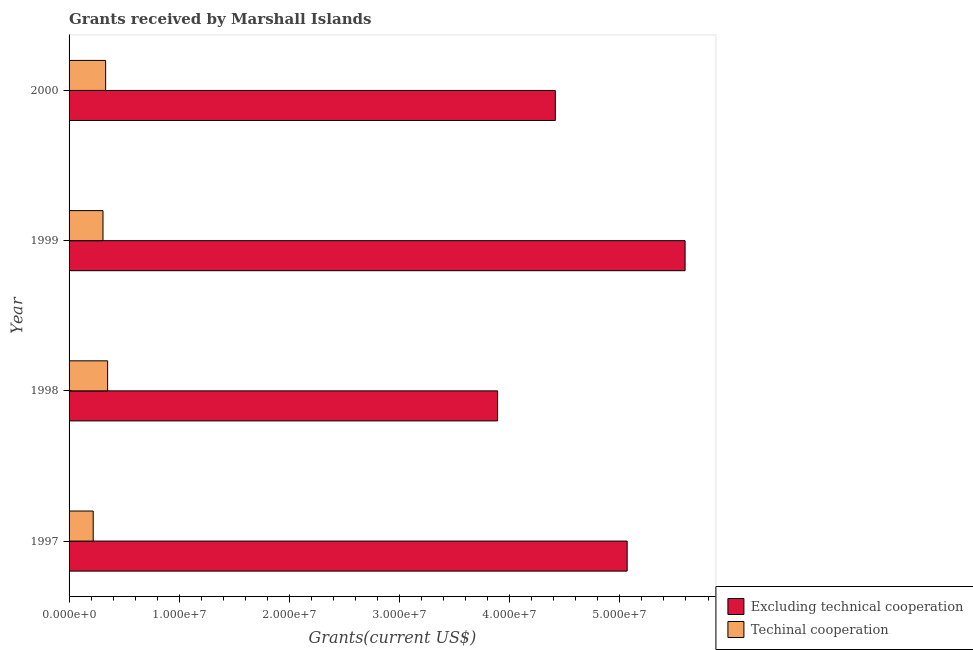How many different coloured bars are there?
Offer a very short reply. 2. How many groups of bars are there?
Ensure brevity in your answer.  4. What is the label of the 3rd group of bars from the top?
Your answer should be very brief. 1998. In how many cases, is the number of bars for a given year not equal to the number of legend labels?
Keep it short and to the point. 0. What is the amount of grants received(including technical cooperation) in 1997?
Ensure brevity in your answer.  2.19e+06. Across all years, what is the maximum amount of grants received(including technical cooperation)?
Provide a succinct answer. 3.50e+06. Across all years, what is the minimum amount of grants received(excluding technical cooperation)?
Give a very brief answer. 3.89e+07. What is the total amount of grants received(including technical cooperation) in the graph?
Keep it short and to the point. 1.21e+07. What is the difference between the amount of grants received(excluding technical cooperation) in 1998 and that in 2000?
Offer a terse response. -5.24e+06. What is the difference between the amount of grants received(excluding technical cooperation) in 2000 and the amount of grants received(including technical cooperation) in 1999?
Ensure brevity in your answer.  4.11e+07. What is the average amount of grants received(excluding technical cooperation) per year?
Give a very brief answer. 4.74e+07. In the year 1998, what is the difference between the amount of grants received(including technical cooperation) and amount of grants received(excluding technical cooperation)?
Make the answer very short. -3.54e+07. In how many years, is the amount of grants received(including technical cooperation) greater than 14000000 US$?
Your answer should be very brief. 0. What is the ratio of the amount of grants received(excluding technical cooperation) in 1997 to that in 1999?
Give a very brief answer. 0.91. Is the difference between the amount of grants received(including technical cooperation) in 1998 and 1999 greater than the difference between the amount of grants received(excluding technical cooperation) in 1998 and 1999?
Your answer should be compact. Yes. What is the difference between the highest and the second highest amount of grants received(excluding technical cooperation)?
Your answer should be compact. 5.26e+06. What is the difference between the highest and the lowest amount of grants received(excluding technical cooperation)?
Provide a succinct answer. 1.70e+07. Is the sum of the amount of grants received(excluding technical cooperation) in 1999 and 2000 greater than the maximum amount of grants received(including technical cooperation) across all years?
Your answer should be compact. Yes. What does the 2nd bar from the top in 1998 represents?
Your response must be concise. Excluding technical cooperation. What does the 1st bar from the bottom in 1998 represents?
Offer a very short reply. Excluding technical cooperation. How many bars are there?
Give a very brief answer. 8. Are all the bars in the graph horizontal?
Your answer should be very brief. Yes. What is the difference between two consecutive major ticks on the X-axis?
Provide a short and direct response. 1.00e+07. Where does the legend appear in the graph?
Ensure brevity in your answer.  Bottom right. What is the title of the graph?
Make the answer very short. Grants received by Marshall Islands. Does "Technicians" appear as one of the legend labels in the graph?
Give a very brief answer. No. What is the label or title of the X-axis?
Provide a short and direct response. Grants(current US$). What is the Grants(current US$) of Excluding technical cooperation in 1997?
Your response must be concise. 5.07e+07. What is the Grants(current US$) of Techinal cooperation in 1997?
Provide a succinct answer. 2.19e+06. What is the Grants(current US$) in Excluding technical cooperation in 1998?
Give a very brief answer. 3.89e+07. What is the Grants(current US$) in Techinal cooperation in 1998?
Make the answer very short. 3.50e+06. What is the Grants(current US$) in Excluding technical cooperation in 1999?
Provide a short and direct response. 5.59e+07. What is the Grants(current US$) in Techinal cooperation in 1999?
Make the answer very short. 3.08e+06. What is the Grants(current US$) in Excluding technical cooperation in 2000?
Provide a short and direct response. 4.41e+07. What is the Grants(current US$) in Techinal cooperation in 2000?
Make the answer very short. 3.32e+06. Across all years, what is the maximum Grants(current US$) in Excluding technical cooperation?
Give a very brief answer. 5.59e+07. Across all years, what is the maximum Grants(current US$) in Techinal cooperation?
Keep it short and to the point. 3.50e+06. Across all years, what is the minimum Grants(current US$) in Excluding technical cooperation?
Provide a short and direct response. 3.89e+07. Across all years, what is the minimum Grants(current US$) in Techinal cooperation?
Your response must be concise. 2.19e+06. What is the total Grants(current US$) of Excluding technical cooperation in the graph?
Your answer should be very brief. 1.90e+08. What is the total Grants(current US$) in Techinal cooperation in the graph?
Your answer should be very brief. 1.21e+07. What is the difference between the Grants(current US$) of Excluding technical cooperation in 1997 and that in 1998?
Ensure brevity in your answer.  1.18e+07. What is the difference between the Grants(current US$) in Techinal cooperation in 1997 and that in 1998?
Your answer should be very brief. -1.31e+06. What is the difference between the Grants(current US$) in Excluding technical cooperation in 1997 and that in 1999?
Your answer should be very brief. -5.26e+06. What is the difference between the Grants(current US$) of Techinal cooperation in 1997 and that in 1999?
Your response must be concise. -8.90e+05. What is the difference between the Grants(current US$) in Excluding technical cooperation in 1997 and that in 2000?
Offer a very short reply. 6.52e+06. What is the difference between the Grants(current US$) in Techinal cooperation in 1997 and that in 2000?
Make the answer very short. -1.13e+06. What is the difference between the Grants(current US$) of Excluding technical cooperation in 1998 and that in 1999?
Your answer should be compact. -1.70e+07. What is the difference between the Grants(current US$) in Excluding technical cooperation in 1998 and that in 2000?
Your response must be concise. -5.24e+06. What is the difference between the Grants(current US$) in Excluding technical cooperation in 1999 and that in 2000?
Your response must be concise. 1.18e+07. What is the difference between the Grants(current US$) in Techinal cooperation in 1999 and that in 2000?
Your answer should be very brief. -2.40e+05. What is the difference between the Grants(current US$) of Excluding technical cooperation in 1997 and the Grants(current US$) of Techinal cooperation in 1998?
Keep it short and to the point. 4.72e+07. What is the difference between the Grants(current US$) of Excluding technical cooperation in 1997 and the Grants(current US$) of Techinal cooperation in 1999?
Provide a short and direct response. 4.76e+07. What is the difference between the Grants(current US$) of Excluding technical cooperation in 1997 and the Grants(current US$) of Techinal cooperation in 2000?
Offer a very short reply. 4.73e+07. What is the difference between the Grants(current US$) of Excluding technical cooperation in 1998 and the Grants(current US$) of Techinal cooperation in 1999?
Ensure brevity in your answer.  3.58e+07. What is the difference between the Grants(current US$) of Excluding technical cooperation in 1998 and the Grants(current US$) of Techinal cooperation in 2000?
Give a very brief answer. 3.56e+07. What is the difference between the Grants(current US$) of Excluding technical cooperation in 1999 and the Grants(current US$) of Techinal cooperation in 2000?
Offer a terse response. 5.26e+07. What is the average Grants(current US$) in Excluding technical cooperation per year?
Your answer should be very brief. 4.74e+07. What is the average Grants(current US$) in Techinal cooperation per year?
Give a very brief answer. 3.02e+06. In the year 1997, what is the difference between the Grants(current US$) in Excluding technical cooperation and Grants(current US$) in Techinal cooperation?
Ensure brevity in your answer.  4.85e+07. In the year 1998, what is the difference between the Grants(current US$) of Excluding technical cooperation and Grants(current US$) of Techinal cooperation?
Your answer should be very brief. 3.54e+07. In the year 1999, what is the difference between the Grants(current US$) in Excluding technical cooperation and Grants(current US$) in Techinal cooperation?
Your answer should be very brief. 5.28e+07. In the year 2000, what is the difference between the Grants(current US$) of Excluding technical cooperation and Grants(current US$) of Techinal cooperation?
Keep it short and to the point. 4.08e+07. What is the ratio of the Grants(current US$) of Excluding technical cooperation in 1997 to that in 1998?
Your response must be concise. 1.3. What is the ratio of the Grants(current US$) in Techinal cooperation in 1997 to that in 1998?
Ensure brevity in your answer.  0.63. What is the ratio of the Grants(current US$) of Excluding technical cooperation in 1997 to that in 1999?
Keep it short and to the point. 0.91. What is the ratio of the Grants(current US$) of Techinal cooperation in 1997 to that in 1999?
Keep it short and to the point. 0.71. What is the ratio of the Grants(current US$) in Excluding technical cooperation in 1997 to that in 2000?
Provide a succinct answer. 1.15. What is the ratio of the Grants(current US$) of Techinal cooperation in 1997 to that in 2000?
Provide a short and direct response. 0.66. What is the ratio of the Grants(current US$) in Excluding technical cooperation in 1998 to that in 1999?
Your answer should be compact. 0.7. What is the ratio of the Grants(current US$) in Techinal cooperation in 1998 to that in 1999?
Your response must be concise. 1.14. What is the ratio of the Grants(current US$) of Excluding technical cooperation in 1998 to that in 2000?
Your answer should be very brief. 0.88. What is the ratio of the Grants(current US$) of Techinal cooperation in 1998 to that in 2000?
Ensure brevity in your answer.  1.05. What is the ratio of the Grants(current US$) of Excluding technical cooperation in 1999 to that in 2000?
Your answer should be very brief. 1.27. What is the ratio of the Grants(current US$) in Techinal cooperation in 1999 to that in 2000?
Offer a very short reply. 0.93. What is the difference between the highest and the second highest Grants(current US$) in Excluding technical cooperation?
Ensure brevity in your answer.  5.26e+06. What is the difference between the highest and the second highest Grants(current US$) of Techinal cooperation?
Give a very brief answer. 1.80e+05. What is the difference between the highest and the lowest Grants(current US$) of Excluding technical cooperation?
Offer a very short reply. 1.70e+07. What is the difference between the highest and the lowest Grants(current US$) in Techinal cooperation?
Make the answer very short. 1.31e+06. 